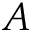<formula> <loc_0><loc_0><loc_500><loc_500>A</formula> 